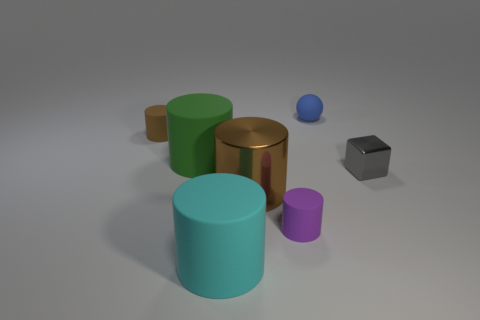There is a rubber cylinder that is the same color as the big metal object; what size is it?
Provide a short and direct response. Small. There is a large shiny cylinder; is it the same color as the tiny thing to the left of the cyan rubber cylinder?
Ensure brevity in your answer.  Yes. Are there any purple objects of the same size as the matte sphere?
Your answer should be compact. Yes. There is a purple object that is the same size as the matte ball; what is its material?
Make the answer very short. Rubber. What number of gray objects are on the left side of the blue matte sphere?
Give a very brief answer. 0. Do the big thing that is on the left side of the big cyan cylinder and the tiny brown object have the same shape?
Ensure brevity in your answer.  Yes. Is there a big cyan thing of the same shape as the tiny brown thing?
Your answer should be compact. Yes. What shape is the big matte object in front of the brown cylinder that is right of the cyan thing?
Offer a very short reply. Cylinder. What number of tiny brown cylinders have the same material as the purple cylinder?
Ensure brevity in your answer.  1. The sphere that is made of the same material as the green cylinder is what color?
Your answer should be very brief. Blue. 